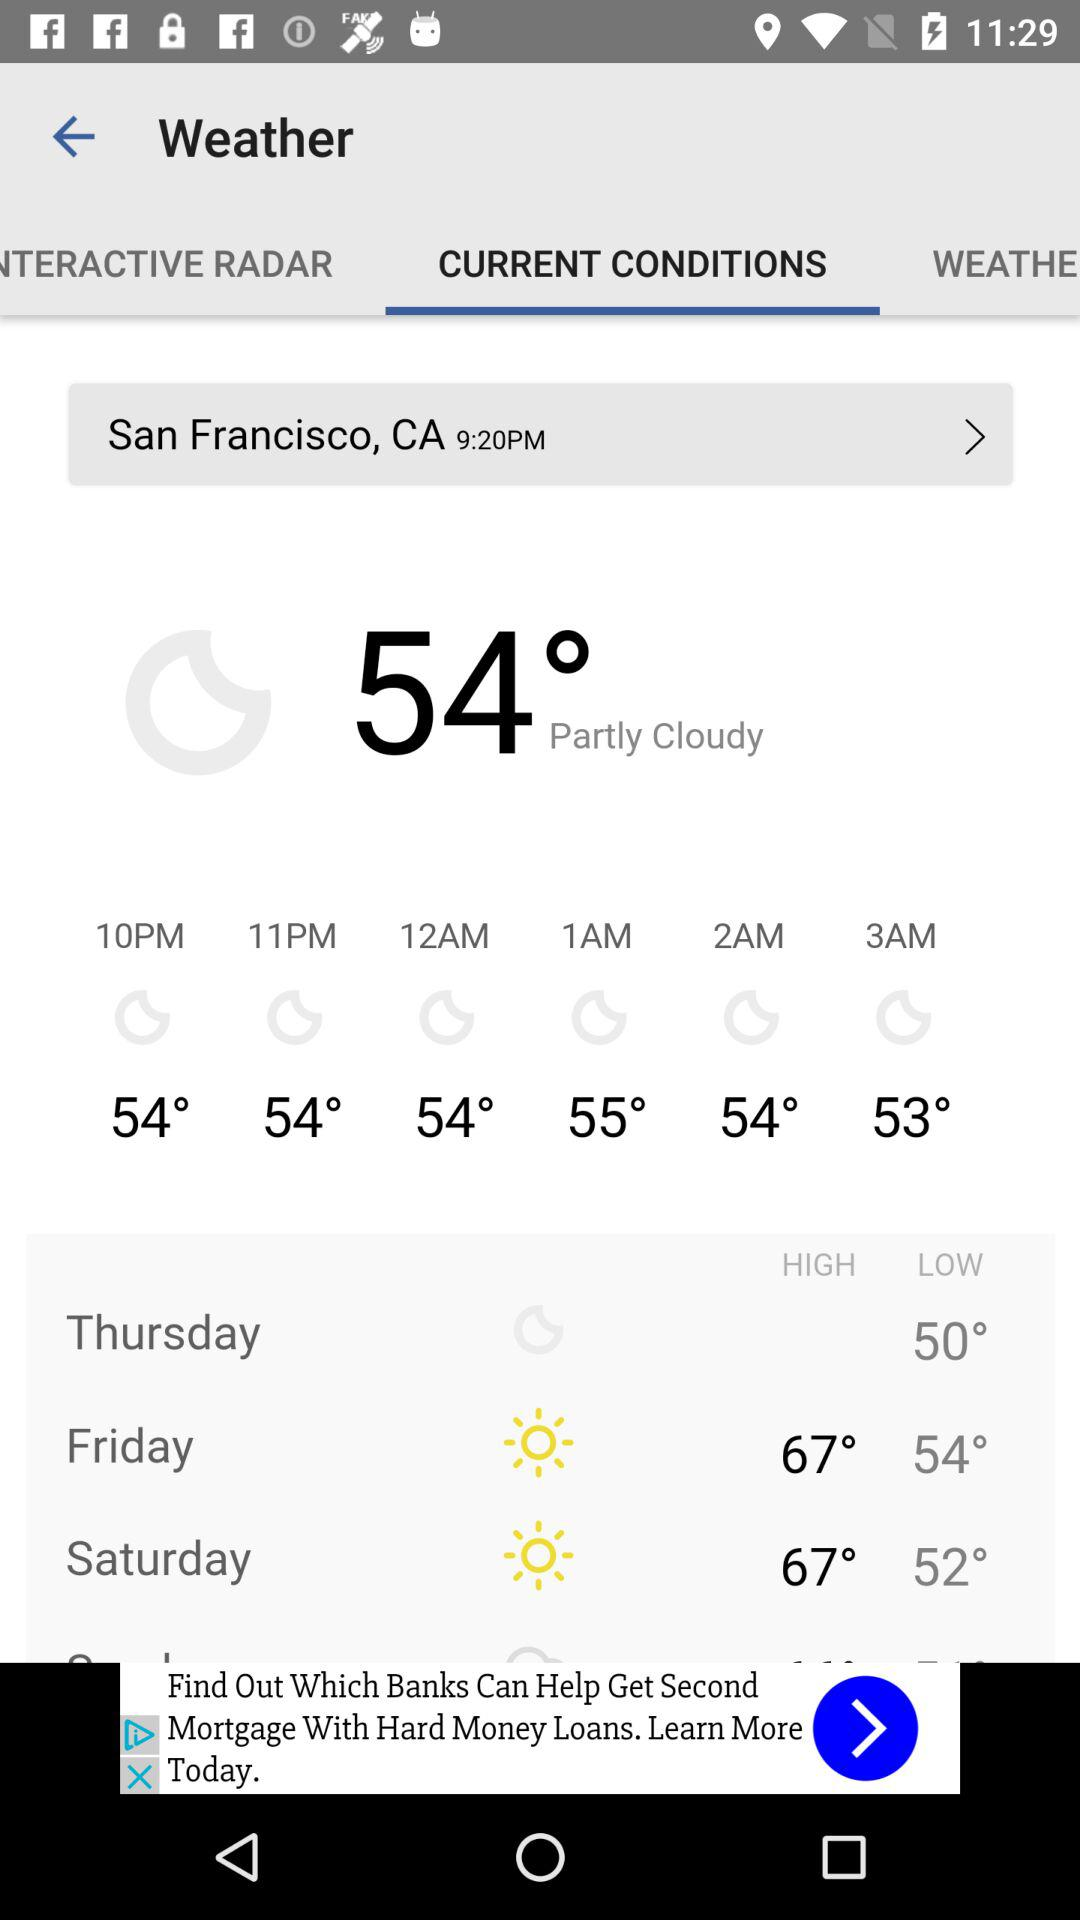What's the lowest temperature on Saturday? The lowest temperature is 52°. 